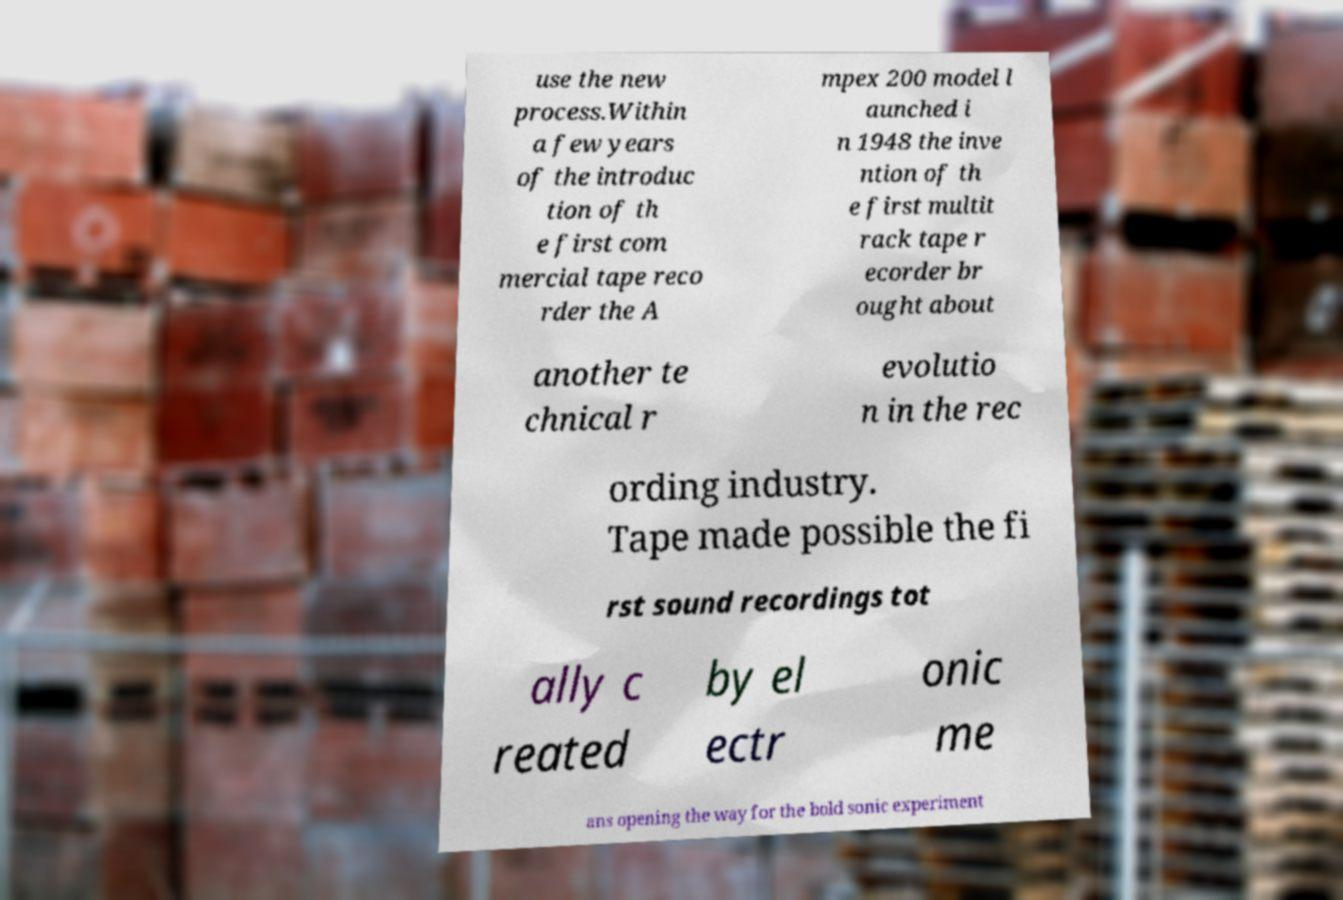For documentation purposes, I need the text within this image transcribed. Could you provide that? use the new process.Within a few years of the introduc tion of th e first com mercial tape reco rder the A mpex 200 model l aunched i n 1948 the inve ntion of th e first multit rack tape r ecorder br ought about another te chnical r evolutio n in the rec ording industry. Tape made possible the fi rst sound recordings tot ally c reated by el ectr onic me ans opening the way for the bold sonic experiment 